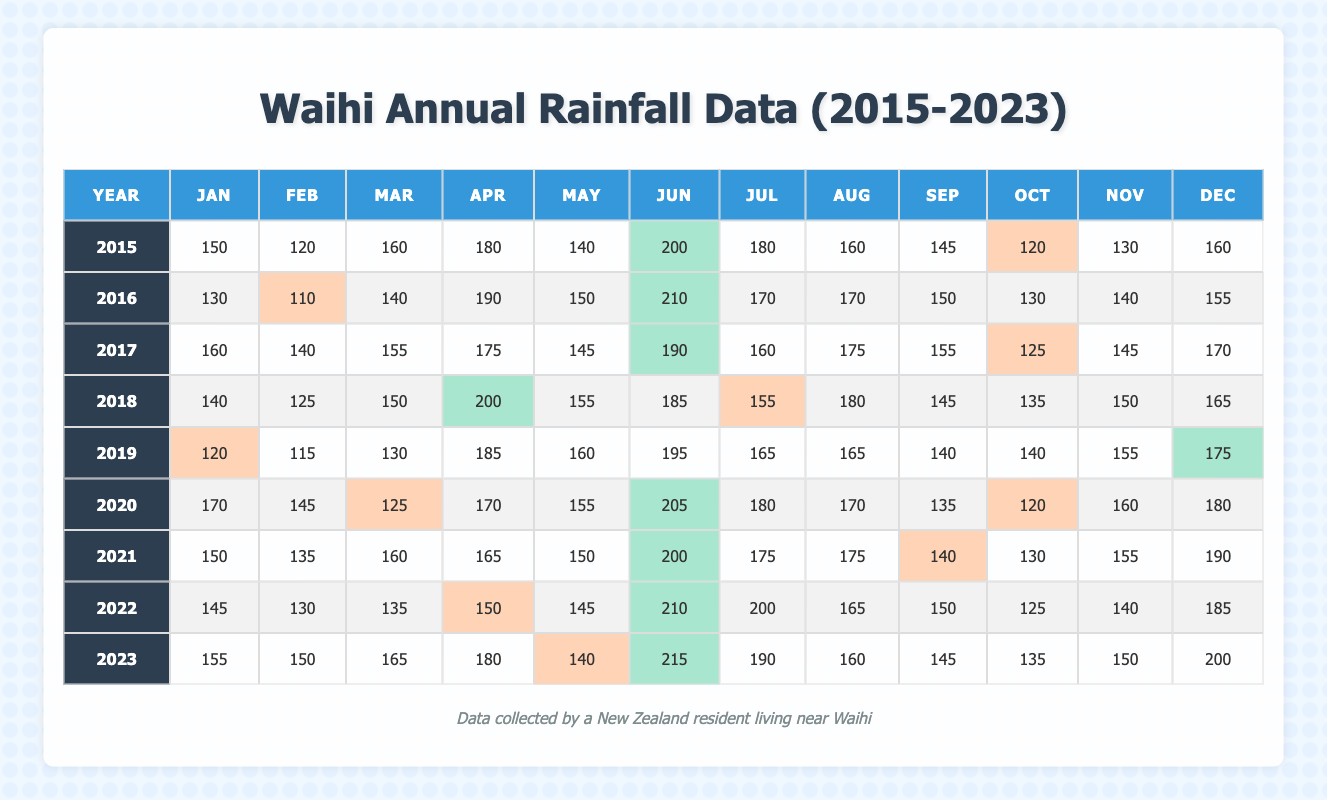What was the total rainfall for Waihi in 2020? To find the total rainfall in 2020, we need to sum the monthly rainfall values: 170 + 145 + 125 + 170 + 155 + 205 + 180 + 170 + 135 + 120 + 160 + 180 = 1,770.
Answer: 1770 Which month had the highest rainfall in 2021? By comparing the monthly values for 2021, June has the highest rainfall at 200.
Answer: June What was the average monthly rainfall for Waihi in 2019? To calculate the average for 2019, sum the monthly values: 120 + 115 + 130 + 185 + 160 + 195 + 165 + 165 + 140 + 140 + 155 + 175 = 1,870. Then divide this total by 12 months: 1870 / 12 = 155.83.
Answer: 155.83 Did Waihi experience a lower rainfall in February 2016 than in February 2015? In February 2016, the rainfall was 110, while in February 2015, it was 120, making 2016 lower than 2015.
Answer: Yes What was the total rainfall in the month of June from 2015 to 2023? We sum the rainfall for June across all years, which is 200 + 210 + 190 + 185 + 195 + 205 + 200 + 210 + 215 = 1,710.
Answer: 1710 In which year did Waihi have the lowest total rainfall? Calculate the total for each year: 2015 = 1,780, 2016 = 1,680, 2017 = 1,700, 2018 = 1,635, 2019 = 1,545, 2020 = 1,770, 2021 = 1,800, 2022 = 1,750, 2023 = 1,725. The lowest total rainfall was in 2019 with 1,545.
Answer: 2019 Which two months saw a significant decrease in rainfall from 2020 to 2021? Comparing the months, October decreased from 120 in 2020 to 130 in 2021, and May saw a decrease from 155 in 2020 to 150 in 2021. Only November increased but all months compared show differences, with May being the most notable decrease.
Answer: May and October What is the median rainfall for Waihi in the month of March over the years? First, list the March values: 160, 140, 155, 150, 130, 125, 160, 135, 165. Then, sort them: 125, 130, 135, 140, 150, 155, 160, 160, 165. The median is the middle number, which is 150.
Answer: 150 Was there an increase in December rainfall from 2022 to 2023? December rainfall in 2022 was 185, and in 2023 it was 200, indicating an increase.
Answer: Yes How many years had a rainfall above 1,800 mm in total? After calculating the annual totals: Years above 1,800 mm are 2015, 2016, 2017, 2021, 2022, and 2020, which totals to 5 years.
Answer: 5 